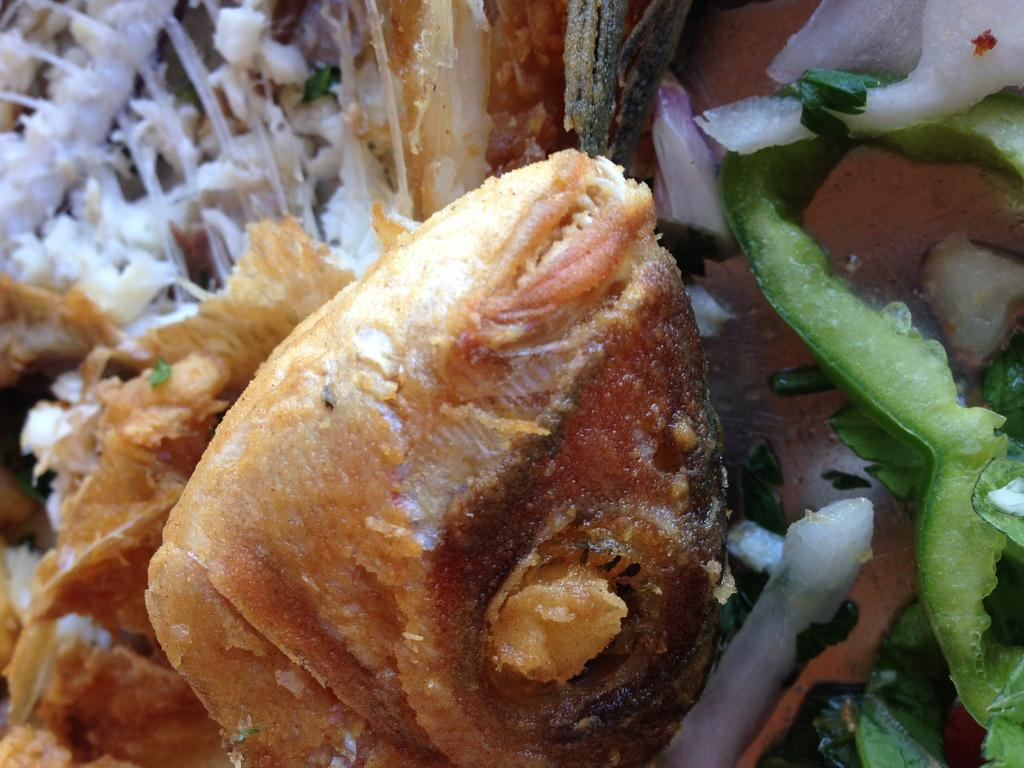What type of food item can be seen in the image? There is a food item in the image, but the specific type is not mentioned in the facts. What other food items are present in the image? The facts mention vegetable salads near the food item. What degree does the rail have in the image? There is no rail present in the image, so it is not possible to determine its degree. 